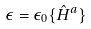<formula> <loc_0><loc_0><loc_500><loc_500>\epsilon = \epsilon _ { 0 } \{ \hat { H } ^ { a } \}</formula> 